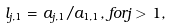Convert formula to latex. <formula><loc_0><loc_0><loc_500><loc_500>l _ { j , 1 } & = a _ { j , 1 } / a _ { 1 , 1 } , f o r j > 1 ,</formula> 